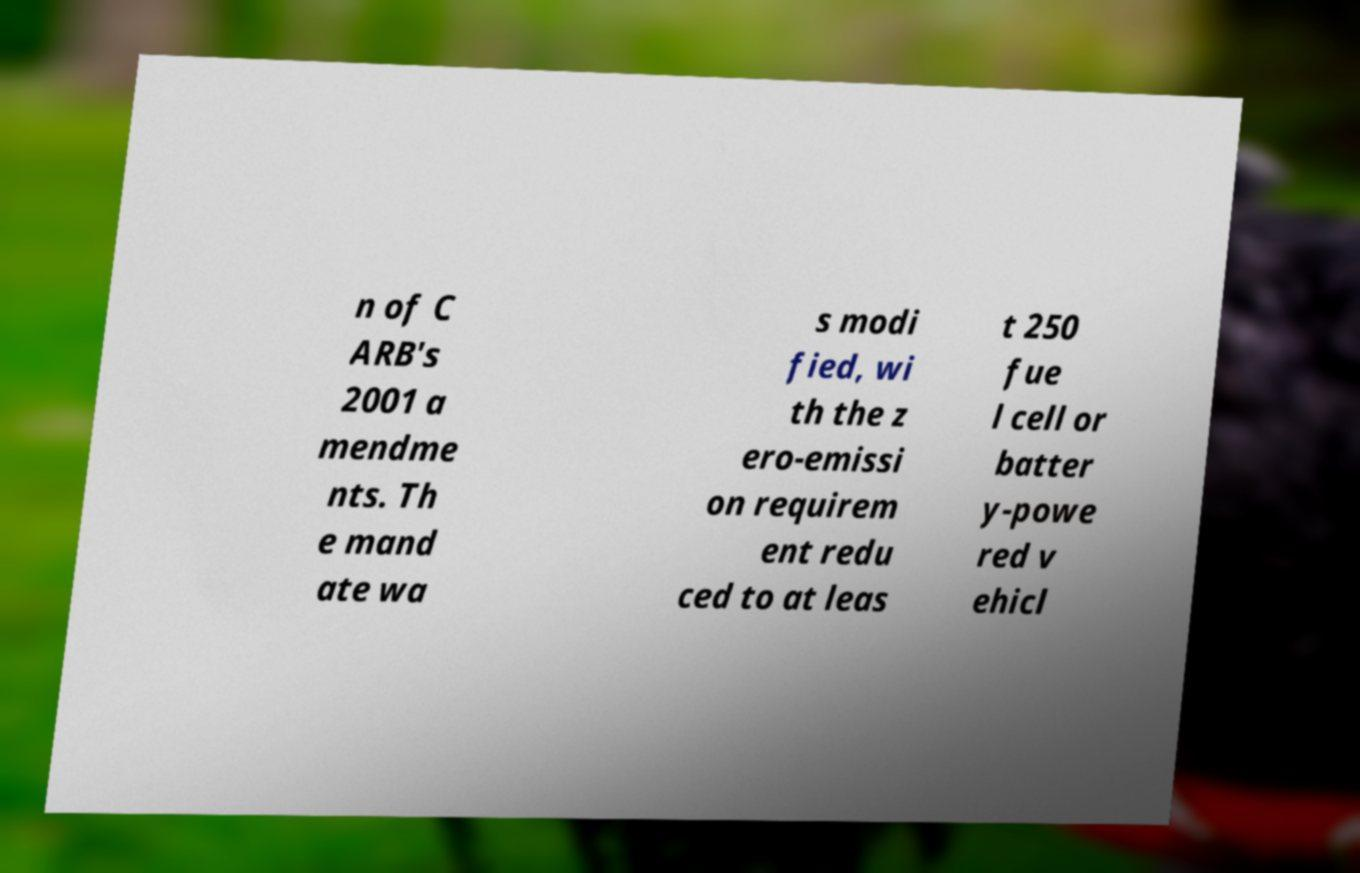I need the written content from this picture converted into text. Can you do that? n of C ARB's 2001 a mendme nts. Th e mand ate wa s modi fied, wi th the z ero-emissi on requirem ent redu ced to at leas t 250 fue l cell or batter y-powe red v ehicl 